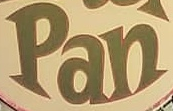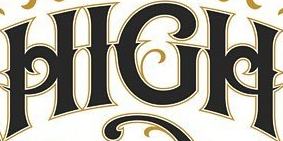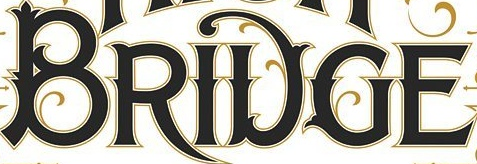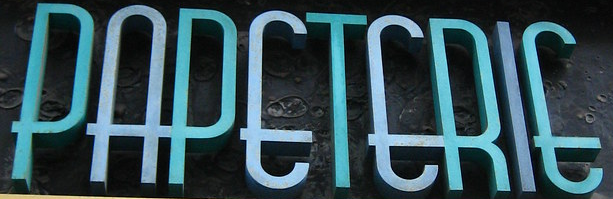Read the text content from these images in order, separated by a semicolon. Pan; HIGH; BRIDGE; PAPETERIE 